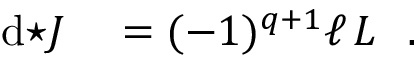Convert formula to latex. <formula><loc_0><loc_0><loc_500><loc_500>\begin{array} { r l } { d { ^ { * } J } } & = ( - 1 ) ^ { q + 1 } \ell \, L . } \end{array}</formula> 